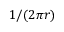Convert formula to latex. <formula><loc_0><loc_0><loc_500><loc_500>1 / ( 2 \pi r )</formula> 